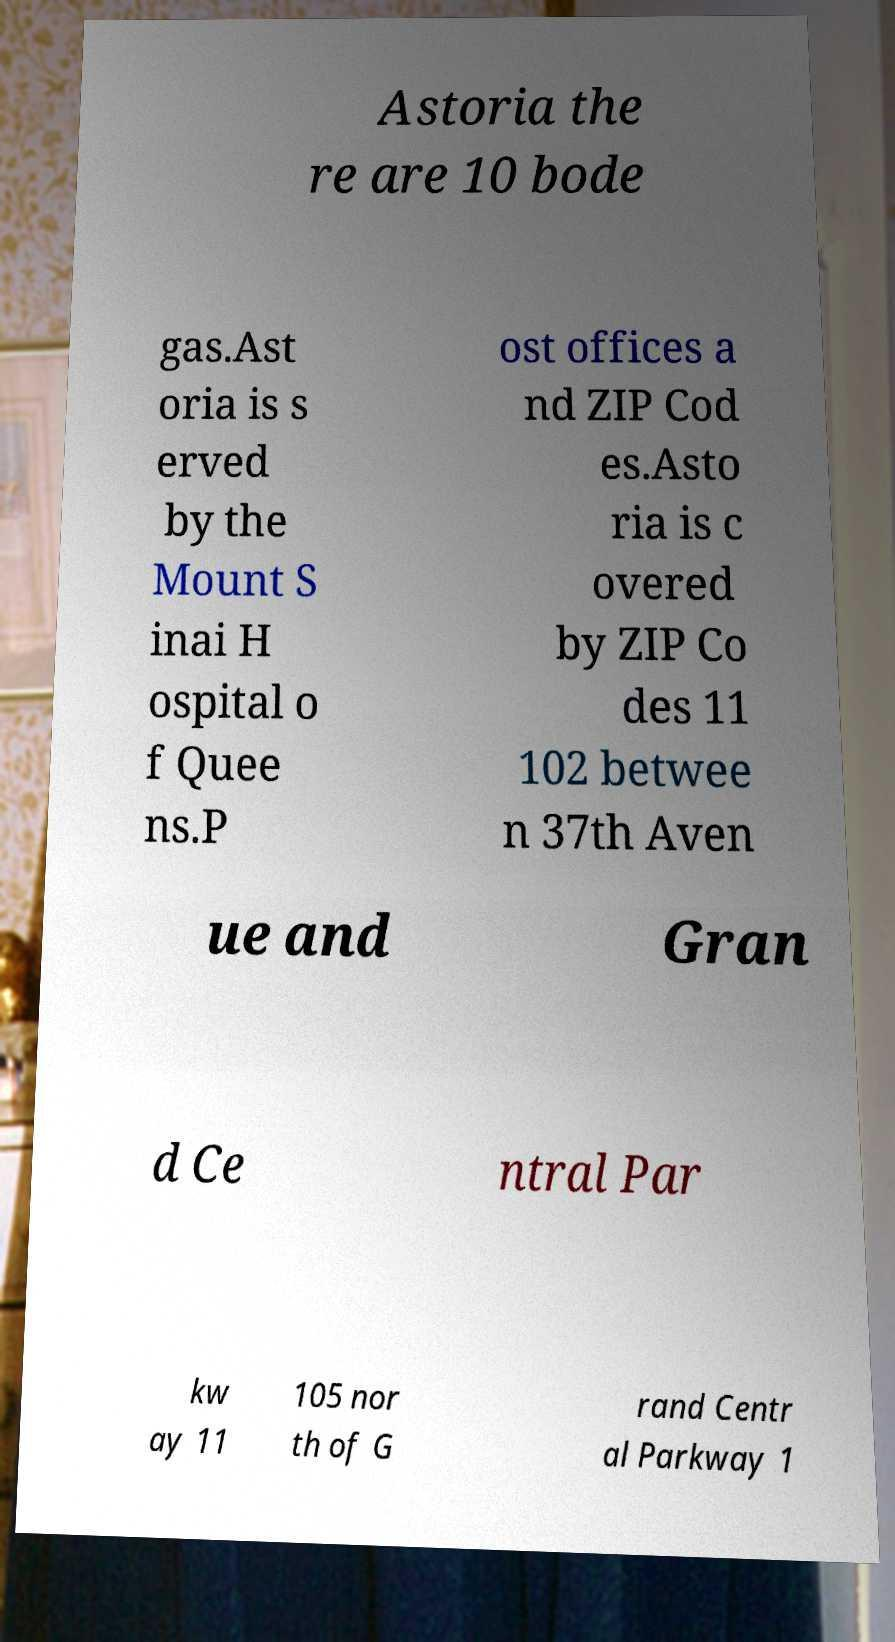Can you read and provide the text displayed in the image?This photo seems to have some interesting text. Can you extract and type it out for me? Astoria the re are 10 bode gas.Ast oria is s erved by the Mount S inai H ospital o f Quee ns.P ost offices a nd ZIP Cod es.Asto ria is c overed by ZIP Co des 11 102 betwee n 37th Aven ue and Gran d Ce ntral Par kw ay 11 105 nor th of G rand Centr al Parkway 1 